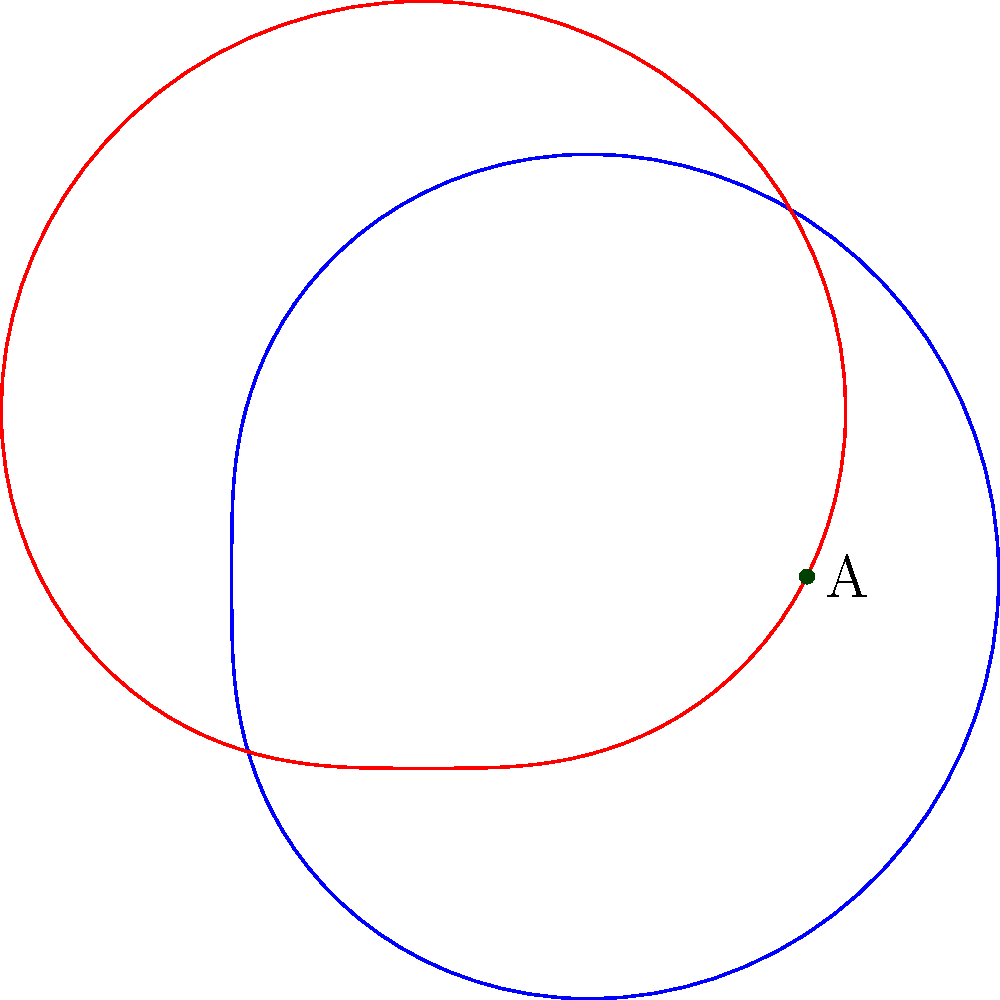In eHarmony's user matching algorithm, two potential matches are represented by intersecting polar curves $r_1 = 2 + \cos(\theta)$ (blue) and $r_2 = 2 + \sin(\theta)$ (red). The point of intersection closest to the origin represents the optimal match. What are the polar coordinates $(r,\theta)$ of this optimal match point? To find the optimal match point, we need to follow these steps:

1) Find the points of intersection by equating the two curves:
   $2 + \cos(\theta) = 2 + \sin(\theta)$
   $\cos(\theta) = \sin(\theta)$

2) This equation is satisfied when $\theta = \frac{\pi}{4}$ or $\theta = \frac{5\pi}{4}$

3) Calculate $r$ for both $\theta$ values:
   For $\theta = \frac{\pi}{4}$: $r = 2 + \cos(\frac{\pi}{4}) = 2 + \frac{\sqrt{2}}{2} \approx 2.71$
   For $\theta = \frac{5\pi}{4}$: $r = 2 + \cos(\frac{5\pi}{4}) = 2 - \frac{\sqrt{2}}{2} \approx 1.29$

4) The point closest to the origin has the smaller $r$ value, which is at $\theta = \frac{5\pi}{4}$

5) Therefore, the optimal match point has polar coordinates $(r,\theta) = (2 - \frac{\sqrt{2}}{2}, \frac{5\pi}{4})$
Answer: $(2 - \frac{\sqrt{2}}{2}, \frac{5\pi}{4})$ 